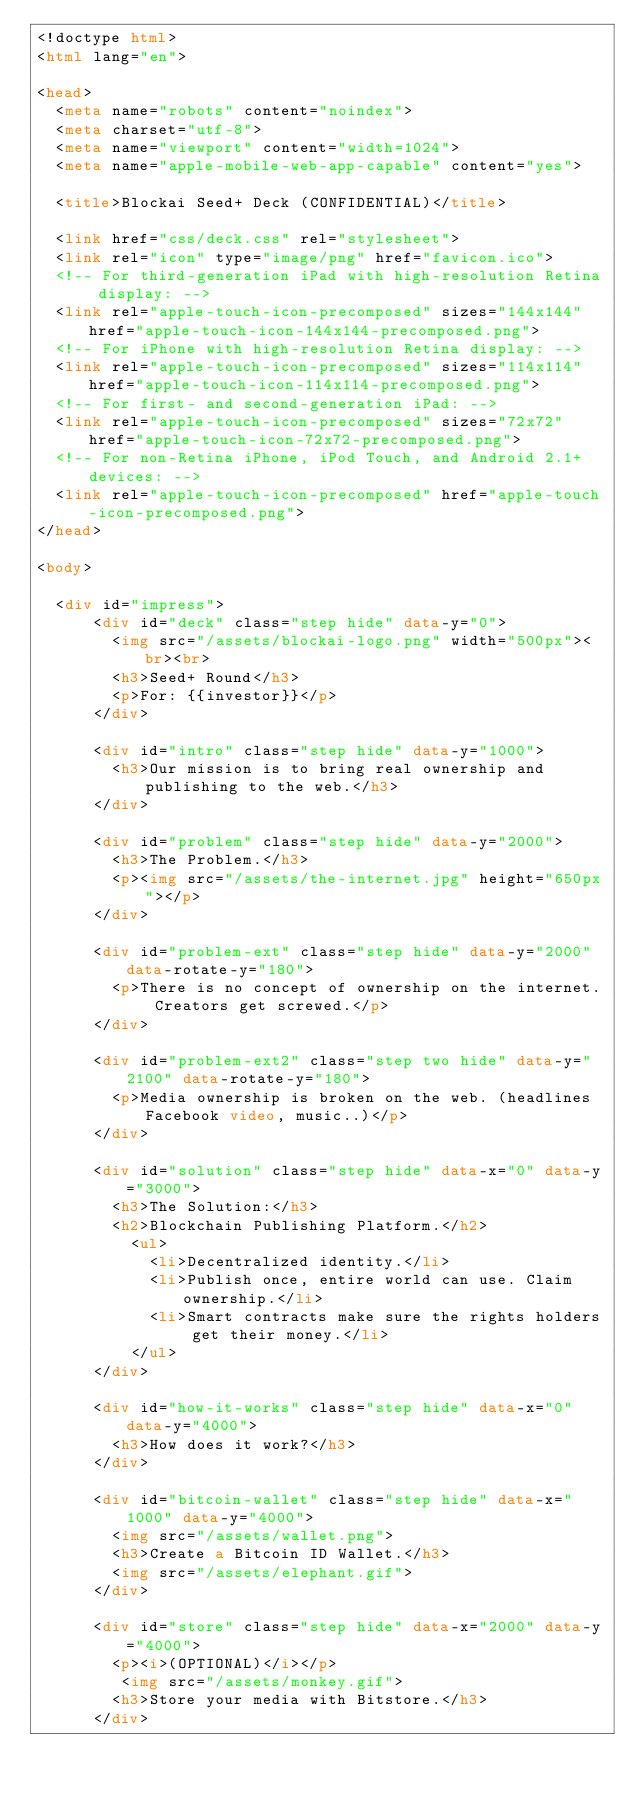<code> <loc_0><loc_0><loc_500><loc_500><_HTML_><!doctype html>
<html lang="en">

<head>
  <meta name="robots" content="noindex">
  <meta charset="utf-8">
  <meta name="viewport" content="width=1024">
  <meta name="apple-mobile-web-app-capable" content="yes">

  <title>Blockai Seed+ Deck (CONFIDENTIAL)</title>

  <link href="css/deck.css" rel="stylesheet">
  <link rel="icon" type="image/png" href="favicon.ico">
  <!-- For third-generation iPad with high-resolution Retina display: -->
  <link rel="apple-touch-icon-precomposed" sizes="144x144" href="apple-touch-icon-144x144-precomposed.png">
  <!-- For iPhone with high-resolution Retina display: -->
  <link rel="apple-touch-icon-precomposed" sizes="114x114" href="apple-touch-icon-114x114-precomposed.png">
  <!-- For first- and second-generation iPad: -->
  <link rel="apple-touch-icon-precomposed" sizes="72x72" href="apple-touch-icon-72x72-precomposed.png">
  <!-- For non-Retina iPhone, iPod Touch, and Android 2.1+ devices: -->
  <link rel="apple-touch-icon-precomposed" href="apple-touch-icon-precomposed.png">
</head>

<body>

  <div id="impress">
      <div id="deck" class="step hide" data-y="0">
        <img src="/assets/blockai-logo.png" width="500px"><br><br>
        <h3>Seed+ Round</h3>
        <p>For: {{investor}}</p>
      </div>

      <div id="intro" class="step hide" data-y="1000">
        <h3>Our mission is to bring real ownership and publishing to the web.</h3>
      </div>

      <div id="problem" class="step hide" data-y="2000">
        <h3>The Problem.</h3>
        <p><img src="/assets/the-internet.jpg" height="650px"></p>
      </div>

      <div id="problem-ext" class="step hide" data-y="2000" data-rotate-y="180">
        <p>There is no concept of ownership on the internet. Creators get screwed.</p>
      </div>

      <div id="problem-ext2" class="step two hide" data-y="2100" data-rotate-y="180">
        <p>Media ownership is broken on the web. (headlines Facebook video, music..)</p>
      </div>

      <div id="solution" class="step hide" data-x="0" data-y="3000">
        <h3>The Solution:</h3>
        <h2>Blockchain Publishing Platform.</h2>
          <ul>
            <li>Decentralized identity.</li>
            <li>Publish once, entire world can use. Claim ownership.</li>
            <li>Smart contracts make sure the rights holders get their money.</li>
          </ul>
      </div>

      <div id="how-it-works" class="step hide" data-x="0" data-y="4000">
        <h3>How does it work?</h3>
      </div>

      <div id="bitcoin-wallet" class="step hide" data-x="1000" data-y="4000">
        <img src="/assets/wallet.png">
        <h3>Create a Bitcoin ID Wallet.</h3>
        <img src="/assets/elephant.gif">
      </div>

      <div id="store" class="step hide" data-x="2000" data-y="4000">
        <p><i>(OPTIONAL)</i></p>
         <img src="/assets/monkey.gif">
        <h3>Store your media with Bitstore.</h3>
      </div>
</code> 